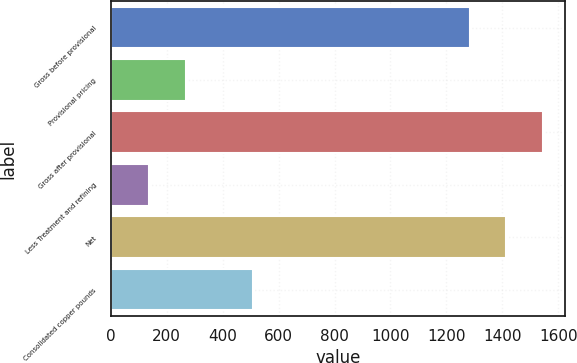Convert chart to OTSL. <chart><loc_0><loc_0><loc_500><loc_500><bar_chart><fcel>Gross before provisional<fcel>Provisional pricing<fcel>Gross after provisional<fcel>Less Treatment and refining<fcel>Net<fcel>Consolidated copper pounds<nl><fcel>1283<fcel>268.9<fcel>1546.8<fcel>137<fcel>1414.9<fcel>507<nl></chart> 